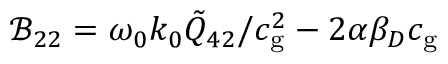Convert formula to latex. <formula><loc_0><loc_0><loc_500><loc_500>\mathcal { B } _ { 2 2 } = \omega _ { 0 } k _ { 0 } \tilde { Q } _ { 4 2 } / c _ { g } ^ { 2 } - 2 \alpha \beta _ { D } c _ { g }</formula> 